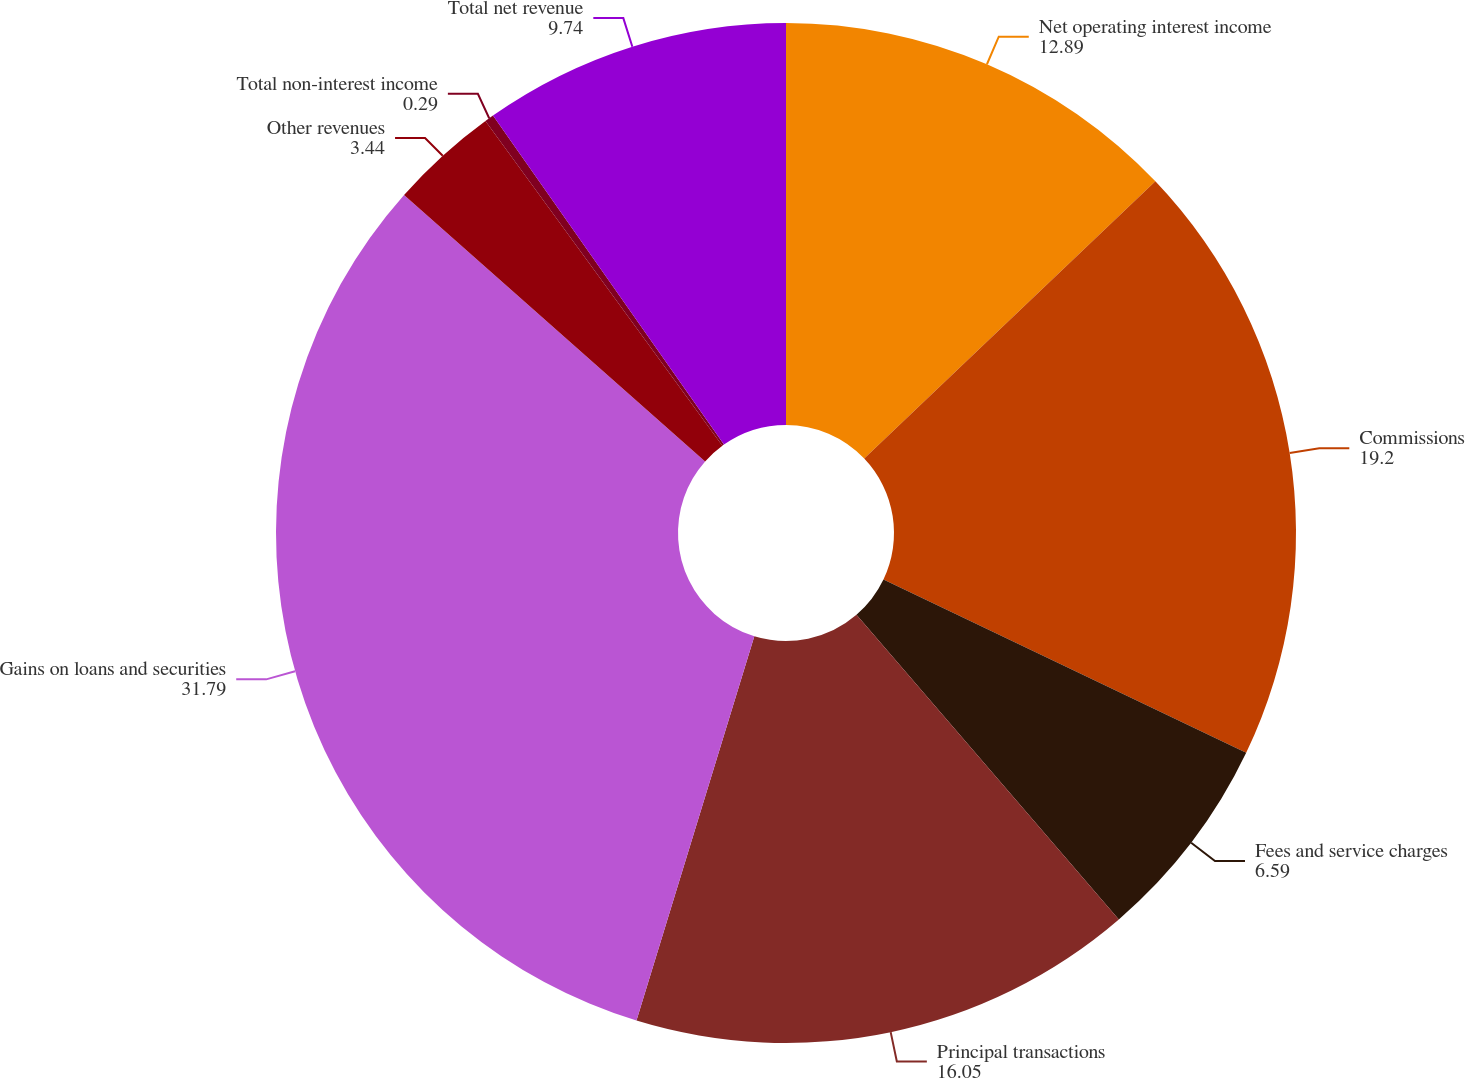Convert chart. <chart><loc_0><loc_0><loc_500><loc_500><pie_chart><fcel>Net operating interest income<fcel>Commissions<fcel>Fees and service charges<fcel>Principal transactions<fcel>Gains on loans and securities<fcel>Other revenues<fcel>Total non-interest income<fcel>Total net revenue<nl><fcel>12.89%<fcel>19.2%<fcel>6.59%<fcel>16.05%<fcel>31.79%<fcel>3.44%<fcel>0.29%<fcel>9.74%<nl></chart> 